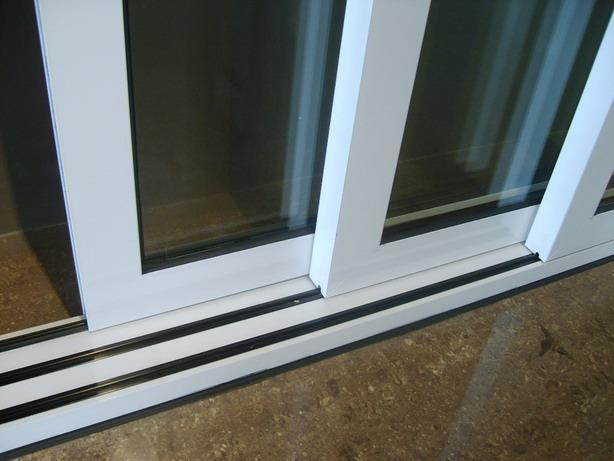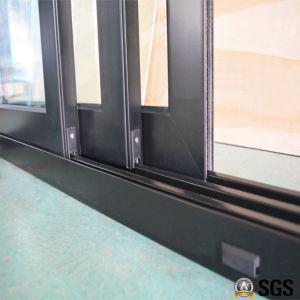The first image is the image on the left, the second image is the image on the right. Analyze the images presented: Is the assertion "The metal framed door in the image on the right is opened just a bit." valid? Answer yes or no. Yes. The first image is the image on the left, the second image is the image on the right. For the images shown, is this caption "An image shows tracks and three sliding glass doors with dark frames." true? Answer yes or no. Yes. 